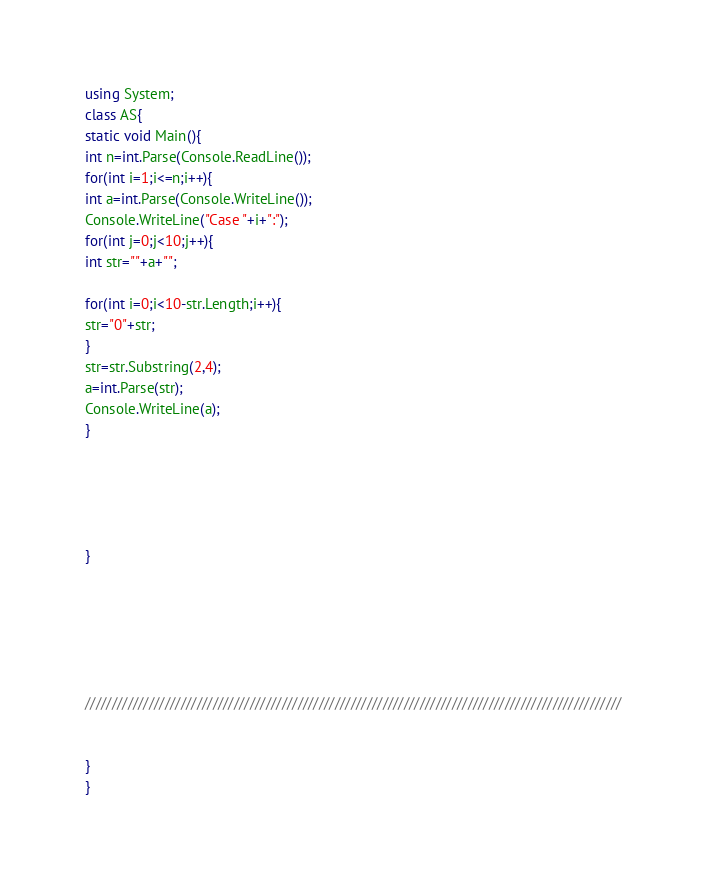<code> <loc_0><loc_0><loc_500><loc_500><_C#_>using System;
class AS{
static void Main(){
int n=int.Parse(Console.ReadLine());
for(int i=1;i<=n;i++){
int a=int.Parse(Console.WriteLine());
Console.WriteLine("Case "+i+":");
for(int j=0;j<10;j++){
int str=""+a+"";

for(int i=0;i<10-str.Length;i++){
str="0"+str;
}
str=str.Substring(2,4);
a=int.Parse(str);
Console.WriteLine(a);
}





}






/////////////////////////////////////////////////////////////////////////////////////////////////////


}
}</code> 